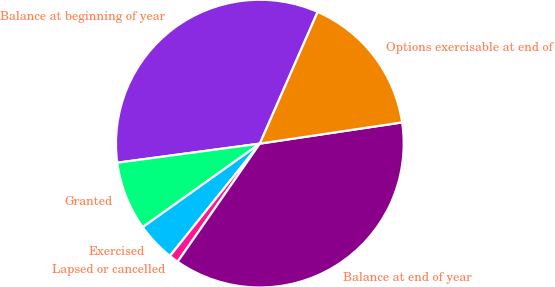<chart> <loc_0><loc_0><loc_500><loc_500><pie_chart><fcel>Balance at beginning of year<fcel>Granted<fcel>Exercised<fcel>Lapsed or cancelled<fcel>Balance at end of year<fcel>Options exercisable at end of<nl><fcel>33.7%<fcel>7.74%<fcel>4.4%<fcel>1.06%<fcel>37.03%<fcel>16.06%<nl></chart> 